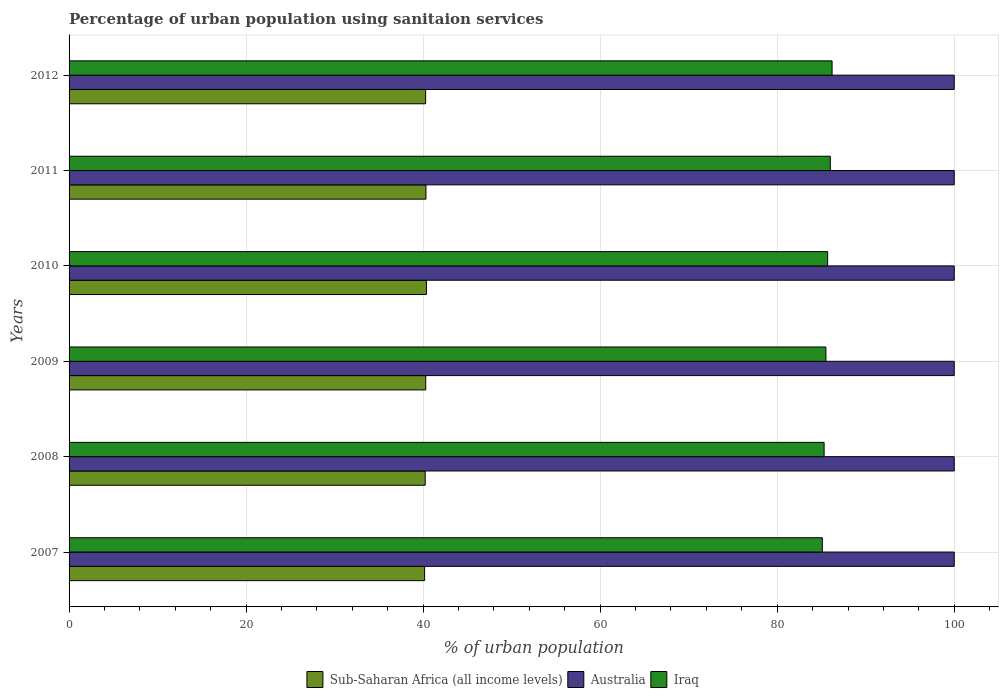How many different coloured bars are there?
Keep it short and to the point. 3. How many groups of bars are there?
Your answer should be compact. 6. Are the number of bars on each tick of the Y-axis equal?
Give a very brief answer. Yes. How many bars are there on the 1st tick from the bottom?
Make the answer very short. 3. In how many cases, is the number of bars for a given year not equal to the number of legend labels?
Your answer should be very brief. 0. What is the percentage of urban population using sanitaion services in Iraq in 2008?
Your response must be concise. 85.3. Across all years, what is the maximum percentage of urban population using sanitaion services in Iraq?
Your answer should be compact. 86.2. Across all years, what is the minimum percentage of urban population using sanitaion services in Australia?
Your answer should be compact. 100. In which year was the percentage of urban population using sanitaion services in Australia maximum?
Provide a succinct answer. 2007. What is the total percentage of urban population using sanitaion services in Iraq in the graph?
Your answer should be compact. 513.8. What is the difference between the percentage of urban population using sanitaion services in Sub-Saharan Africa (all income levels) in 2010 and the percentage of urban population using sanitaion services in Iraq in 2011?
Give a very brief answer. -45.63. What is the average percentage of urban population using sanitaion services in Iraq per year?
Offer a very short reply. 85.63. In the year 2007, what is the difference between the percentage of urban population using sanitaion services in Sub-Saharan Africa (all income levels) and percentage of urban population using sanitaion services in Australia?
Offer a terse response. -59.83. What is the ratio of the percentage of urban population using sanitaion services in Sub-Saharan Africa (all income levels) in 2007 to that in 2010?
Make the answer very short. 0.99. Is the percentage of urban population using sanitaion services in Sub-Saharan Africa (all income levels) in 2007 less than that in 2011?
Keep it short and to the point. Yes. What is the difference between the highest and the second highest percentage of urban population using sanitaion services in Sub-Saharan Africa (all income levels)?
Give a very brief answer. 0.05. What is the difference between the highest and the lowest percentage of urban population using sanitaion services in Australia?
Your response must be concise. 0. In how many years, is the percentage of urban population using sanitaion services in Iraq greater than the average percentage of urban population using sanitaion services in Iraq taken over all years?
Offer a very short reply. 3. Is the sum of the percentage of urban population using sanitaion services in Iraq in 2009 and 2011 greater than the maximum percentage of urban population using sanitaion services in Australia across all years?
Keep it short and to the point. Yes. What does the 2nd bar from the top in 2009 represents?
Provide a succinct answer. Australia. What does the 3rd bar from the bottom in 2012 represents?
Ensure brevity in your answer.  Iraq. Are the values on the major ticks of X-axis written in scientific E-notation?
Your answer should be very brief. No. Where does the legend appear in the graph?
Your answer should be compact. Bottom center. How many legend labels are there?
Keep it short and to the point. 3. How are the legend labels stacked?
Offer a very short reply. Horizontal. What is the title of the graph?
Offer a very short reply. Percentage of urban population using sanitaion services. What is the label or title of the X-axis?
Ensure brevity in your answer.  % of urban population. What is the label or title of the Y-axis?
Your answer should be compact. Years. What is the % of urban population of Sub-Saharan Africa (all income levels) in 2007?
Offer a terse response. 40.17. What is the % of urban population of Iraq in 2007?
Provide a short and direct response. 85.1. What is the % of urban population in Sub-Saharan Africa (all income levels) in 2008?
Provide a short and direct response. 40.23. What is the % of urban population of Australia in 2008?
Your answer should be compact. 100. What is the % of urban population in Iraq in 2008?
Offer a terse response. 85.3. What is the % of urban population in Sub-Saharan Africa (all income levels) in 2009?
Offer a terse response. 40.29. What is the % of urban population of Australia in 2009?
Provide a succinct answer. 100. What is the % of urban population in Iraq in 2009?
Give a very brief answer. 85.5. What is the % of urban population in Sub-Saharan Africa (all income levels) in 2010?
Ensure brevity in your answer.  40.37. What is the % of urban population in Iraq in 2010?
Your response must be concise. 85.7. What is the % of urban population in Sub-Saharan Africa (all income levels) in 2011?
Your answer should be very brief. 40.32. What is the % of urban population of Australia in 2011?
Provide a succinct answer. 100. What is the % of urban population in Sub-Saharan Africa (all income levels) in 2012?
Your answer should be very brief. 40.28. What is the % of urban population in Australia in 2012?
Make the answer very short. 100. What is the % of urban population of Iraq in 2012?
Your response must be concise. 86.2. Across all years, what is the maximum % of urban population in Sub-Saharan Africa (all income levels)?
Make the answer very short. 40.37. Across all years, what is the maximum % of urban population in Iraq?
Keep it short and to the point. 86.2. Across all years, what is the minimum % of urban population of Sub-Saharan Africa (all income levels)?
Ensure brevity in your answer.  40.17. Across all years, what is the minimum % of urban population of Iraq?
Your answer should be compact. 85.1. What is the total % of urban population of Sub-Saharan Africa (all income levels) in the graph?
Your answer should be compact. 241.67. What is the total % of urban population of Australia in the graph?
Provide a succinct answer. 600. What is the total % of urban population of Iraq in the graph?
Ensure brevity in your answer.  513.8. What is the difference between the % of urban population in Sub-Saharan Africa (all income levels) in 2007 and that in 2008?
Provide a succinct answer. -0.07. What is the difference between the % of urban population in Sub-Saharan Africa (all income levels) in 2007 and that in 2009?
Your answer should be very brief. -0.13. What is the difference between the % of urban population of Australia in 2007 and that in 2009?
Keep it short and to the point. 0. What is the difference between the % of urban population in Iraq in 2007 and that in 2009?
Provide a succinct answer. -0.4. What is the difference between the % of urban population of Sub-Saharan Africa (all income levels) in 2007 and that in 2010?
Your answer should be very brief. -0.21. What is the difference between the % of urban population of Australia in 2007 and that in 2010?
Your answer should be very brief. 0. What is the difference between the % of urban population of Sub-Saharan Africa (all income levels) in 2007 and that in 2011?
Give a very brief answer. -0.15. What is the difference between the % of urban population of Sub-Saharan Africa (all income levels) in 2007 and that in 2012?
Make the answer very short. -0.12. What is the difference between the % of urban population in Australia in 2007 and that in 2012?
Give a very brief answer. 0. What is the difference between the % of urban population of Sub-Saharan Africa (all income levels) in 2008 and that in 2009?
Keep it short and to the point. -0.06. What is the difference between the % of urban population of Australia in 2008 and that in 2009?
Ensure brevity in your answer.  0. What is the difference between the % of urban population in Iraq in 2008 and that in 2009?
Your answer should be very brief. -0.2. What is the difference between the % of urban population of Sub-Saharan Africa (all income levels) in 2008 and that in 2010?
Provide a succinct answer. -0.14. What is the difference between the % of urban population in Australia in 2008 and that in 2010?
Your answer should be very brief. 0. What is the difference between the % of urban population in Iraq in 2008 and that in 2010?
Your response must be concise. -0.4. What is the difference between the % of urban population in Sub-Saharan Africa (all income levels) in 2008 and that in 2011?
Your response must be concise. -0.09. What is the difference between the % of urban population of Iraq in 2008 and that in 2011?
Your answer should be compact. -0.7. What is the difference between the % of urban population of Sub-Saharan Africa (all income levels) in 2008 and that in 2012?
Provide a succinct answer. -0.05. What is the difference between the % of urban population in Australia in 2008 and that in 2012?
Keep it short and to the point. 0. What is the difference between the % of urban population of Sub-Saharan Africa (all income levels) in 2009 and that in 2010?
Offer a very short reply. -0.08. What is the difference between the % of urban population in Sub-Saharan Africa (all income levels) in 2009 and that in 2011?
Keep it short and to the point. -0.03. What is the difference between the % of urban population in Sub-Saharan Africa (all income levels) in 2009 and that in 2012?
Provide a short and direct response. 0.01. What is the difference between the % of urban population of Australia in 2009 and that in 2012?
Provide a succinct answer. 0. What is the difference between the % of urban population of Sub-Saharan Africa (all income levels) in 2010 and that in 2011?
Provide a short and direct response. 0.05. What is the difference between the % of urban population of Australia in 2010 and that in 2011?
Your answer should be very brief. 0. What is the difference between the % of urban population in Sub-Saharan Africa (all income levels) in 2010 and that in 2012?
Keep it short and to the point. 0.09. What is the difference between the % of urban population in Australia in 2010 and that in 2012?
Offer a very short reply. 0. What is the difference between the % of urban population in Sub-Saharan Africa (all income levels) in 2011 and that in 2012?
Provide a short and direct response. 0.04. What is the difference between the % of urban population of Australia in 2011 and that in 2012?
Your answer should be compact. 0. What is the difference between the % of urban population in Iraq in 2011 and that in 2012?
Keep it short and to the point. -0.2. What is the difference between the % of urban population in Sub-Saharan Africa (all income levels) in 2007 and the % of urban population in Australia in 2008?
Your answer should be very brief. -59.83. What is the difference between the % of urban population in Sub-Saharan Africa (all income levels) in 2007 and the % of urban population in Iraq in 2008?
Provide a succinct answer. -45.13. What is the difference between the % of urban population of Sub-Saharan Africa (all income levels) in 2007 and the % of urban population of Australia in 2009?
Keep it short and to the point. -59.83. What is the difference between the % of urban population of Sub-Saharan Africa (all income levels) in 2007 and the % of urban population of Iraq in 2009?
Give a very brief answer. -45.33. What is the difference between the % of urban population of Sub-Saharan Africa (all income levels) in 2007 and the % of urban population of Australia in 2010?
Your answer should be very brief. -59.83. What is the difference between the % of urban population of Sub-Saharan Africa (all income levels) in 2007 and the % of urban population of Iraq in 2010?
Provide a short and direct response. -45.53. What is the difference between the % of urban population in Sub-Saharan Africa (all income levels) in 2007 and the % of urban population in Australia in 2011?
Provide a succinct answer. -59.83. What is the difference between the % of urban population of Sub-Saharan Africa (all income levels) in 2007 and the % of urban population of Iraq in 2011?
Give a very brief answer. -45.83. What is the difference between the % of urban population of Australia in 2007 and the % of urban population of Iraq in 2011?
Your answer should be very brief. 14. What is the difference between the % of urban population in Sub-Saharan Africa (all income levels) in 2007 and the % of urban population in Australia in 2012?
Offer a terse response. -59.83. What is the difference between the % of urban population of Sub-Saharan Africa (all income levels) in 2007 and the % of urban population of Iraq in 2012?
Offer a very short reply. -46.03. What is the difference between the % of urban population of Australia in 2007 and the % of urban population of Iraq in 2012?
Offer a terse response. 13.8. What is the difference between the % of urban population of Sub-Saharan Africa (all income levels) in 2008 and the % of urban population of Australia in 2009?
Your answer should be very brief. -59.77. What is the difference between the % of urban population in Sub-Saharan Africa (all income levels) in 2008 and the % of urban population in Iraq in 2009?
Ensure brevity in your answer.  -45.27. What is the difference between the % of urban population in Australia in 2008 and the % of urban population in Iraq in 2009?
Provide a succinct answer. 14.5. What is the difference between the % of urban population in Sub-Saharan Africa (all income levels) in 2008 and the % of urban population in Australia in 2010?
Make the answer very short. -59.77. What is the difference between the % of urban population of Sub-Saharan Africa (all income levels) in 2008 and the % of urban population of Iraq in 2010?
Offer a very short reply. -45.47. What is the difference between the % of urban population in Sub-Saharan Africa (all income levels) in 2008 and the % of urban population in Australia in 2011?
Ensure brevity in your answer.  -59.77. What is the difference between the % of urban population in Sub-Saharan Africa (all income levels) in 2008 and the % of urban population in Iraq in 2011?
Ensure brevity in your answer.  -45.77. What is the difference between the % of urban population in Sub-Saharan Africa (all income levels) in 2008 and the % of urban population in Australia in 2012?
Keep it short and to the point. -59.77. What is the difference between the % of urban population in Sub-Saharan Africa (all income levels) in 2008 and the % of urban population in Iraq in 2012?
Offer a very short reply. -45.97. What is the difference between the % of urban population of Sub-Saharan Africa (all income levels) in 2009 and the % of urban population of Australia in 2010?
Your answer should be very brief. -59.71. What is the difference between the % of urban population of Sub-Saharan Africa (all income levels) in 2009 and the % of urban population of Iraq in 2010?
Give a very brief answer. -45.41. What is the difference between the % of urban population of Sub-Saharan Africa (all income levels) in 2009 and the % of urban population of Australia in 2011?
Give a very brief answer. -59.71. What is the difference between the % of urban population of Sub-Saharan Africa (all income levels) in 2009 and the % of urban population of Iraq in 2011?
Your response must be concise. -45.71. What is the difference between the % of urban population of Sub-Saharan Africa (all income levels) in 2009 and the % of urban population of Australia in 2012?
Your answer should be very brief. -59.71. What is the difference between the % of urban population in Sub-Saharan Africa (all income levels) in 2009 and the % of urban population in Iraq in 2012?
Your answer should be compact. -45.91. What is the difference between the % of urban population in Australia in 2009 and the % of urban population in Iraq in 2012?
Provide a short and direct response. 13.8. What is the difference between the % of urban population in Sub-Saharan Africa (all income levels) in 2010 and the % of urban population in Australia in 2011?
Make the answer very short. -59.63. What is the difference between the % of urban population in Sub-Saharan Africa (all income levels) in 2010 and the % of urban population in Iraq in 2011?
Keep it short and to the point. -45.63. What is the difference between the % of urban population of Australia in 2010 and the % of urban population of Iraq in 2011?
Provide a succinct answer. 14. What is the difference between the % of urban population of Sub-Saharan Africa (all income levels) in 2010 and the % of urban population of Australia in 2012?
Keep it short and to the point. -59.63. What is the difference between the % of urban population of Sub-Saharan Africa (all income levels) in 2010 and the % of urban population of Iraq in 2012?
Your answer should be compact. -45.83. What is the difference between the % of urban population of Sub-Saharan Africa (all income levels) in 2011 and the % of urban population of Australia in 2012?
Offer a very short reply. -59.68. What is the difference between the % of urban population of Sub-Saharan Africa (all income levels) in 2011 and the % of urban population of Iraq in 2012?
Make the answer very short. -45.88. What is the average % of urban population of Sub-Saharan Africa (all income levels) per year?
Offer a terse response. 40.28. What is the average % of urban population of Iraq per year?
Provide a succinct answer. 85.63. In the year 2007, what is the difference between the % of urban population of Sub-Saharan Africa (all income levels) and % of urban population of Australia?
Offer a very short reply. -59.83. In the year 2007, what is the difference between the % of urban population in Sub-Saharan Africa (all income levels) and % of urban population in Iraq?
Your answer should be compact. -44.93. In the year 2007, what is the difference between the % of urban population of Australia and % of urban population of Iraq?
Make the answer very short. 14.9. In the year 2008, what is the difference between the % of urban population of Sub-Saharan Africa (all income levels) and % of urban population of Australia?
Ensure brevity in your answer.  -59.77. In the year 2008, what is the difference between the % of urban population in Sub-Saharan Africa (all income levels) and % of urban population in Iraq?
Your answer should be very brief. -45.07. In the year 2009, what is the difference between the % of urban population of Sub-Saharan Africa (all income levels) and % of urban population of Australia?
Your answer should be very brief. -59.71. In the year 2009, what is the difference between the % of urban population of Sub-Saharan Africa (all income levels) and % of urban population of Iraq?
Your answer should be compact. -45.21. In the year 2010, what is the difference between the % of urban population in Sub-Saharan Africa (all income levels) and % of urban population in Australia?
Your answer should be very brief. -59.63. In the year 2010, what is the difference between the % of urban population of Sub-Saharan Africa (all income levels) and % of urban population of Iraq?
Provide a short and direct response. -45.33. In the year 2011, what is the difference between the % of urban population of Sub-Saharan Africa (all income levels) and % of urban population of Australia?
Keep it short and to the point. -59.68. In the year 2011, what is the difference between the % of urban population in Sub-Saharan Africa (all income levels) and % of urban population in Iraq?
Your answer should be very brief. -45.68. In the year 2012, what is the difference between the % of urban population in Sub-Saharan Africa (all income levels) and % of urban population in Australia?
Offer a terse response. -59.72. In the year 2012, what is the difference between the % of urban population in Sub-Saharan Africa (all income levels) and % of urban population in Iraq?
Your answer should be very brief. -45.92. What is the ratio of the % of urban population of Sub-Saharan Africa (all income levels) in 2007 to that in 2008?
Keep it short and to the point. 1. What is the ratio of the % of urban population of Australia in 2007 to that in 2008?
Your answer should be very brief. 1. What is the ratio of the % of urban population in Iraq in 2007 to that in 2008?
Provide a succinct answer. 1. What is the ratio of the % of urban population of Sub-Saharan Africa (all income levels) in 2007 to that in 2009?
Make the answer very short. 1. What is the ratio of the % of urban population in Australia in 2007 to that in 2009?
Offer a terse response. 1. What is the ratio of the % of urban population of Iraq in 2007 to that in 2009?
Give a very brief answer. 1. What is the ratio of the % of urban population in Sub-Saharan Africa (all income levels) in 2007 to that in 2010?
Ensure brevity in your answer.  0.99. What is the ratio of the % of urban population in Sub-Saharan Africa (all income levels) in 2007 to that in 2011?
Provide a short and direct response. 1. What is the ratio of the % of urban population of Iraq in 2007 to that in 2011?
Your answer should be very brief. 0.99. What is the ratio of the % of urban population in Australia in 2007 to that in 2012?
Give a very brief answer. 1. What is the ratio of the % of urban population in Iraq in 2007 to that in 2012?
Make the answer very short. 0.99. What is the ratio of the % of urban population in Australia in 2008 to that in 2009?
Ensure brevity in your answer.  1. What is the ratio of the % of urban population in Sub-Saharan Africa (all income levels) in 2008 to that in 2010?
Your answer should be compact. 1. What is the ratio of the % of urban population in Australia in 2008 to that in 2010?
Provide a succinct answer. 1. What is the ratio of the % of urban population of Iraq in 2008 to that in 2010?
Ensure brevity in your answer.  1. What is the ratio of the % of urban population in Sub-Saharan Africa (all income levels) in 2008 to that in 2011?
Provide a short and direct response. 1. What is the ratio of the % of urban population in Australia in 2008 to that in 2012?
Your answer should be very brief. 1. What is the ratio of the % of urban population of Sub-Saharan Africa (all income levels) in 2009 to that in 2011?
Ensure brevity in your answer.  1. What is the ratio of the % of urban population of Australia in 2009 to that in 2011?
Provide a succinct answer. 1. What is the ratio of the % of urban population of Australia in 2009 to that in 2012?
Offer a terse response. 1. What is the ratio of the % of urban population in Australia in 2010 to that in 2012?
Your response must be concise. 1. What is the ratio of the % of urban population in Iraq in 2010 to that in 2012?
Ensure brevity in your answer.  0.99. What is the ratio of the % of urban population of Sub-Saharan Africa (all income levels) in 2011 to that in 2012?
Make the answer very short. 1. What is the ratio of the % of urban population of Australia in 2011 to that in 2012?
Offer a terse response. 1. What is the difference between the highest and the second highest % of urban population in Sub-Saharan Africa (all income levels)?
Your response must be concise. 0.05. What is the difference between the highest and the second highest % of urban population of Australia?
Offer a terse response. 0. What is the difference between the highest and the lowest % of urban population in Sub-Saharan Africa (all income levels)?
Your response must be concise. 0.21. 